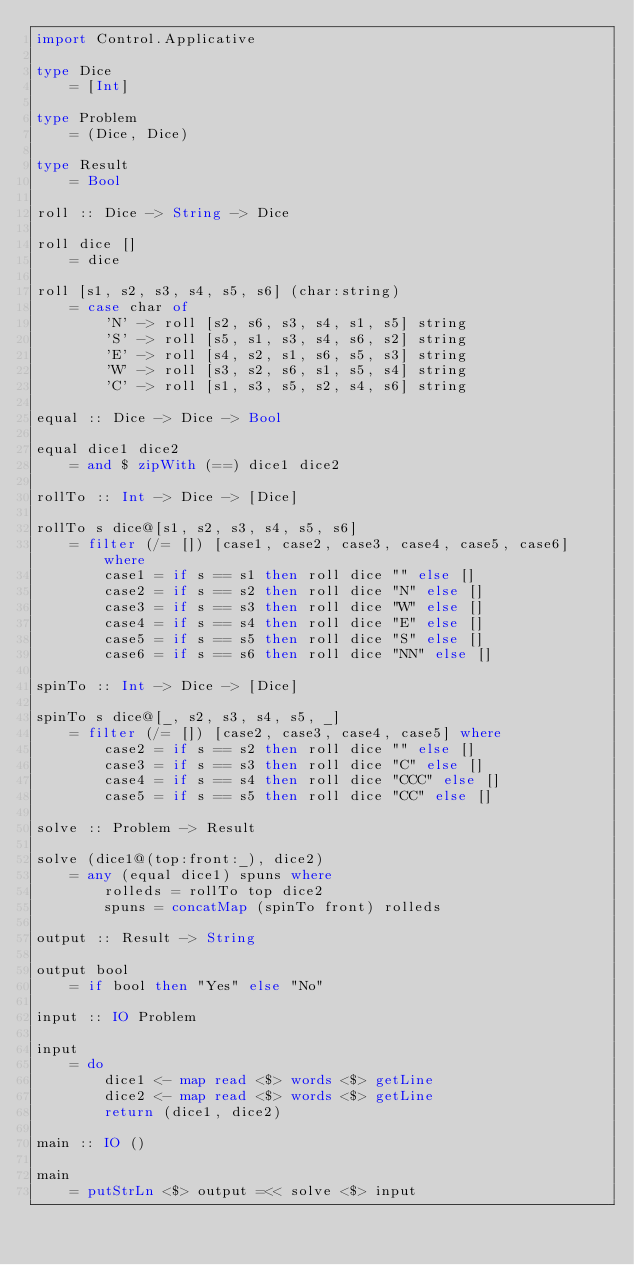Convert code to text. <code><loc_0><loc_0><loc_500><loc_500><_Haskell_>import Control.Applicative

type Dice
    = [Int]

type Problem
    = (Dice, Dice)

type Result
    = Bool

roll :: Dice -> String -> Dice

roll dice []
    = dice

roll [s1, s2, s3, s4, s5, s6] (char:string)
    = case char of
        'N' -> roll [s2, s6, s3, s4, s1, s5] string
        'S' -> roll [s5, s1, s3, s4, s6, s2] string
        'E' -> roll [s4, s2, s1, s6, s5, s3] string
        'W' -> roll [s3, s2, s6, s1, s5, s4] string
        'C' -> roll [s1, s3, s5, s2, s4, s6] string

equal :: Dice -> Dice -> Bool

equal dice1 dice2
    = and $ zipWith (==) dice1 dice2
    
rollTo :: Int -> Dice -> [Dice]

rollTo s dice@[s1, s2, s3, s4, s5, s6]
    = filter (/= []) [case1, case2, case3, case4, case5, case6] where
        case1 = if s == s1 then roll dice "" else []
        case2 = if s == s2 then roll dice "N" else []
        case3 = if s == s3 then roll dice "W" else []
        case4 = if s == s4 then roll dice "E" else []
        case5 = if s == s5 then roll dice "S" else []
        case6 = if s == s6 then roll dice "NN" else []
        
spinTo :: Int -> Dice -> [Dice]

spinTo s dice@[_, s2, s3, s4, s5, _]
    = filter (/= []) [case2, case3, case4, case5] where
        case2 = if s == s2 then roll dice "" else []
        case3 = if s == s3 then roll dice "C" else []
        case4 = if s == s4 then roll dice "CCC" else []
        case5 = if s == s5 then roll dice "CC" else []

solve :: Problem -> Result

solve (dice1@(top:front:_), dice2)
    = any (equal dice1) spuns where
        rolleds = rollTo top dice2
        spuns = concatMap (spinTo front) rolleds

output :: Result -> String

output bool
    = if bool then "Yes" else "No"
    
input :: IO Problem

input
    = do
        dice1 <- map read <$> words <$> getLine
        dice2 <- map read <$> words <$> getLine
        return (dice1, dice2)

main :: IO ()

main
    = putStrLn <$> output =<< solve <$> input</code> 